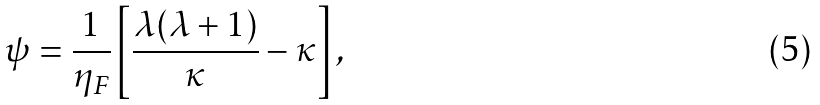Convert formula to latex. <formula><loc_0><loc_0><loc_500><loc_500>\psi = \frac { 1 } { \eta _ { F } } \left [ \frac { \lambda ( \lambda + 1 ) } { \kappa } - \kappa \right ] ,</formula> 